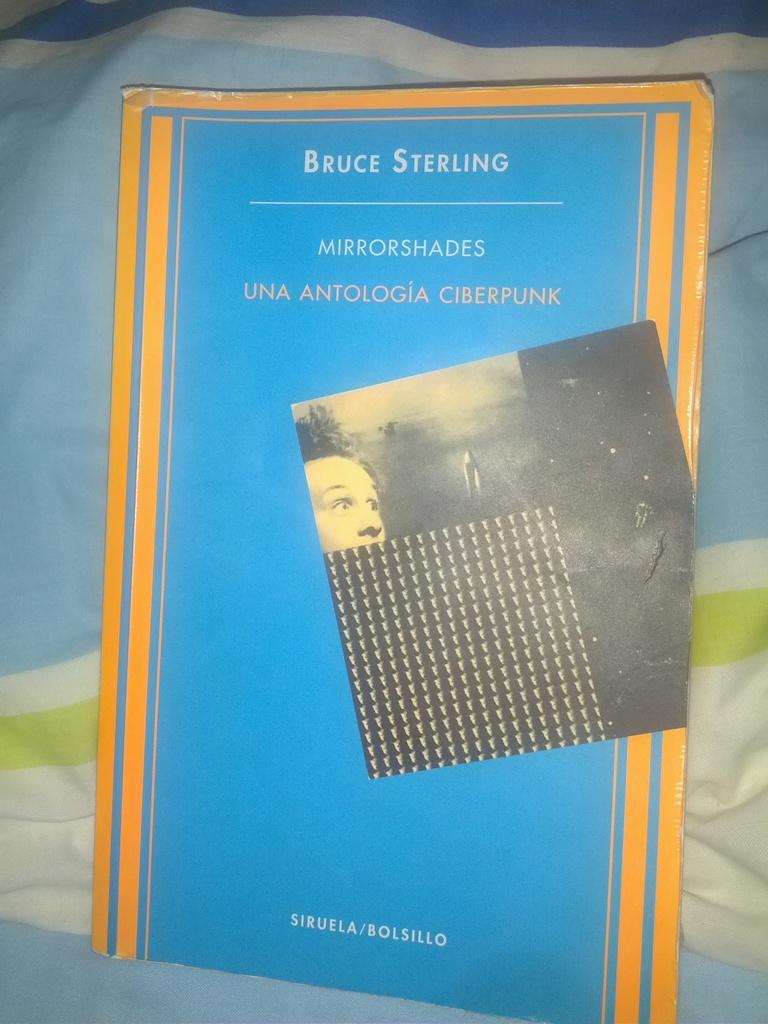Who is the author at the top of the book?
Ensure brevity in your answer.  Bruce sterling. What words are at the bottom of the book cover?
Keep it short and to the point. Siruela/bolsillo. 